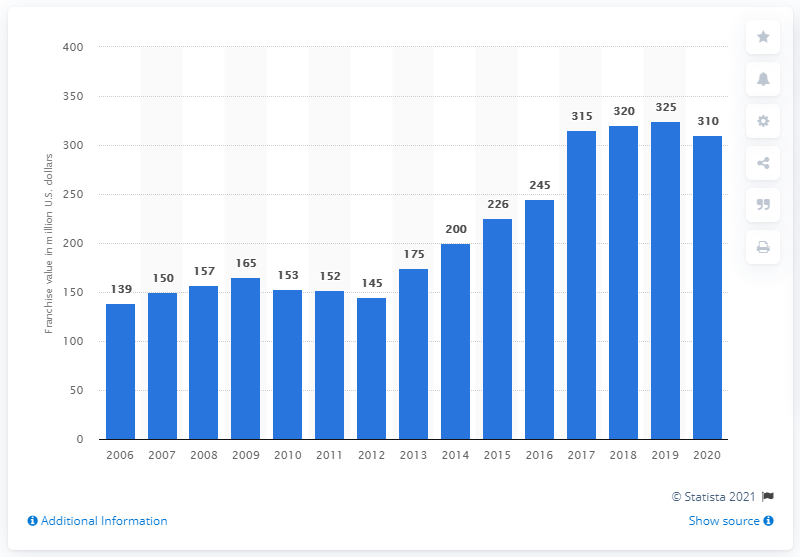Can you explain the trend in the franchise value of the Columbus Blue Jackets from 2006 to 2020? The franchise value of the Columbus Blue Jackets has shown a general upward trend from 2006 to 2020. Starting at 139 million dollars in 2006, the value increased to a peak of 325 million dollars in 2019. The graph indicates steady growth with occasional slight dips and a small decline in 2020. 